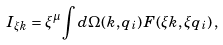Convert formula to latex. <formula><loc_0><loc_0><loc_500><loc_500>I _ { \xi k } = \xi ^ { \mu } \int d \Omega ( k , q _ { i } ) \, F ( \xi k , \xi q _ { i } ) \, ,</formula> 